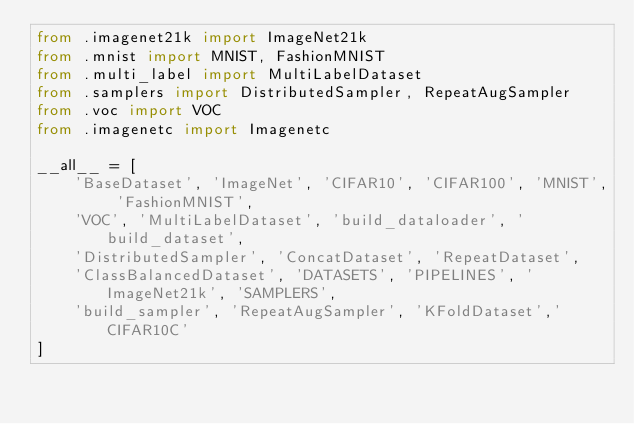Convert code to text. <code><loc_0><loc_0><loc_500><loc_500><_Python_>from .imagenet21k import ImageNet21k
from .mnist import MNIST, FashionMNIST
from .multi_label import MultiLabelDataset
from .samplers import DistributedSampler, RepeatAugSampler
from .voc import VOC
from .imagenetc import Imagenetc

__all__ = [
    'BaseDataset', 'ImageNet', 'CIFAR10', 'CIFAR100', 'MNIST', 'FashionMNIST',
    'VOC', 'MultiLabelDataset', 'build_dataloader', 'build_dataset',
    'DistributedSampler', 'ConcatDataset', 'RepeatDataset',
    'ClassBalancedDataset', 'DATASETS', 'PIPELINES', 'ImageNet21k', 'SAMPLERS',
    'build_sampler', 'RepeatAugSampler', 'KFoldDataset','CIFAR10C'
]
</code> 